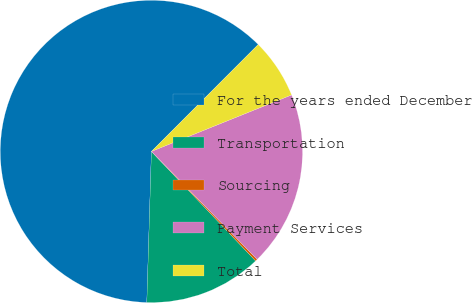<chart> <loc_0><loc_0><loc_500><loc_500><pie_chart><fcel>For the years ended December<fcel>Transportation<fcel>Sourcing<fcel>Payment Services<fcel>Total<nl><fcel>62.0%<fcel>12.59%<fcel>0.23%<fcel>18.76%<fcel>6.41%<nl></chart> 